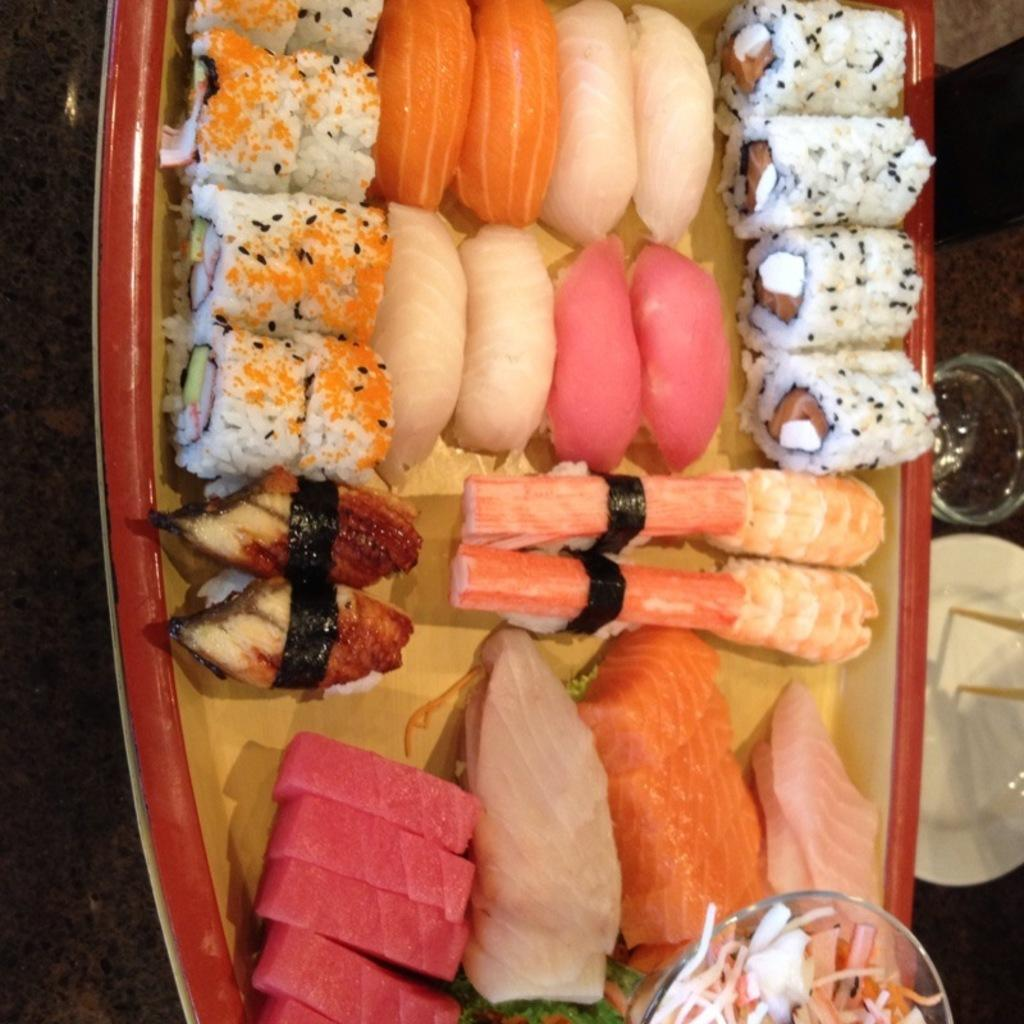What is on the plate in the image? There are food items present in a plate. Where is the plate located? The plate is present on a table. What other items are on the table beside the food plate? There is a plate and a glass present beside the food plate. What is the texture of the baby's skin in the image? There is no baby present in the image, so we cannot determine the texture of the baby's skin. 